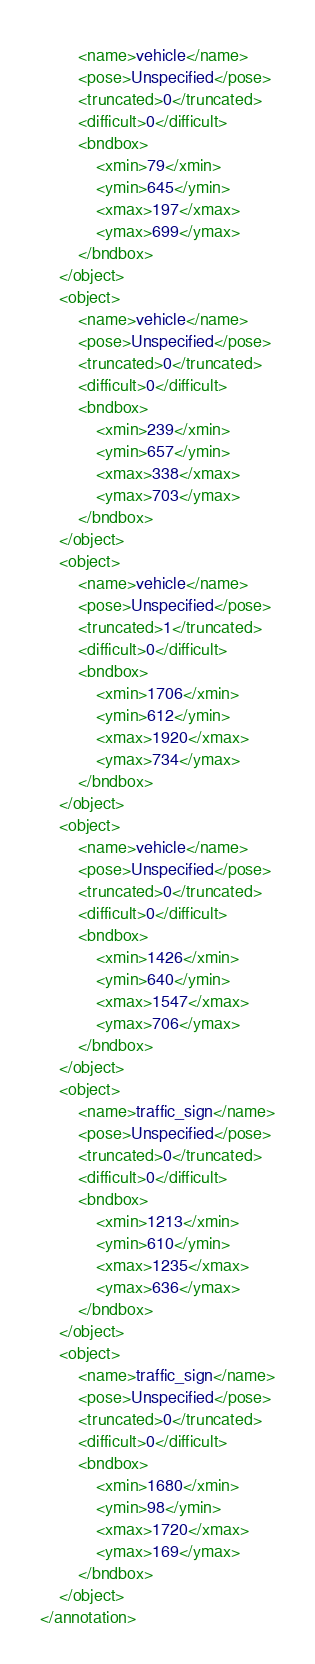<code> <loc_0><loc_0><loc_500><loc_500><_XML_>		<name>vehicle</name>
		<pose>Unspecified</pose>
		<truncated>0</truncated>
		<difficult>0</difficult>
		<bndbox>
			<xmin>79</xmin>
			<ymin>645</ymin>
			<xmax>197</xmax>
			<ymax>699</ymax>
		</bndbox>
	</object>
	<object>
		<name>vehicle</name>
		<pose>Unspecified</pose>
		<truncated>0</truncated>
		<difficult>0</difficult>
		<bndbox>
			<xmin>239</xmin>
			<ymin>657</ymin>
			<xmax>338</xmax>
			<ymax>703</ymax>
		</bndbox>
	</object>
	<object>
		<name>vehicle</name>
		<pose>Unspecified</pose>
		<truncated>1</truncated>
		<difficult>0</difficult>
		<bndbox>
			<xmin>1706</xmin>
			<ymin>612</ymin>
			<xmax>1920</xmax>
			<ymax>734</ymax>
		</bndbox>
	</object>
	<object>
		<name>vehicle</name>
		<pose>Unspecified</pose>
		<truncated>0</truncated>
		<difficult>0</difficult>
		<bndbox>
			<xmin>1426</xmin>
			<ymin>640</ymin>
			<xmax>1547</xmax>
			<ymax>706</ymax>
		</bndbox>
	</object>
	<object>
		<name>traffic_sign</name>
		<pose>Unspecified</pose>
		<truncated>0</truncated>
		<difficult>0</difficult>
		<bndbox>
			<xmin>1213</xmin>
			<ymin>610</ymin>
			<xmax>1235</xmax>
			<ymax>636</ymax>
		</bndbox>
	</object>
	<object>
		<name>traffic_sign</name>
		<pose>Unspecified</pose>
		<truncated>0</truncated>
		<difficult>0</difficult>
		<bndbox>
			<xmin>1680</xmin>
			<ymin>98</ymin>
			<xmax>1720</xmax>
			<ymax>169</ymax>
		</bndbox>
	</object>
</annotation>
</code> 